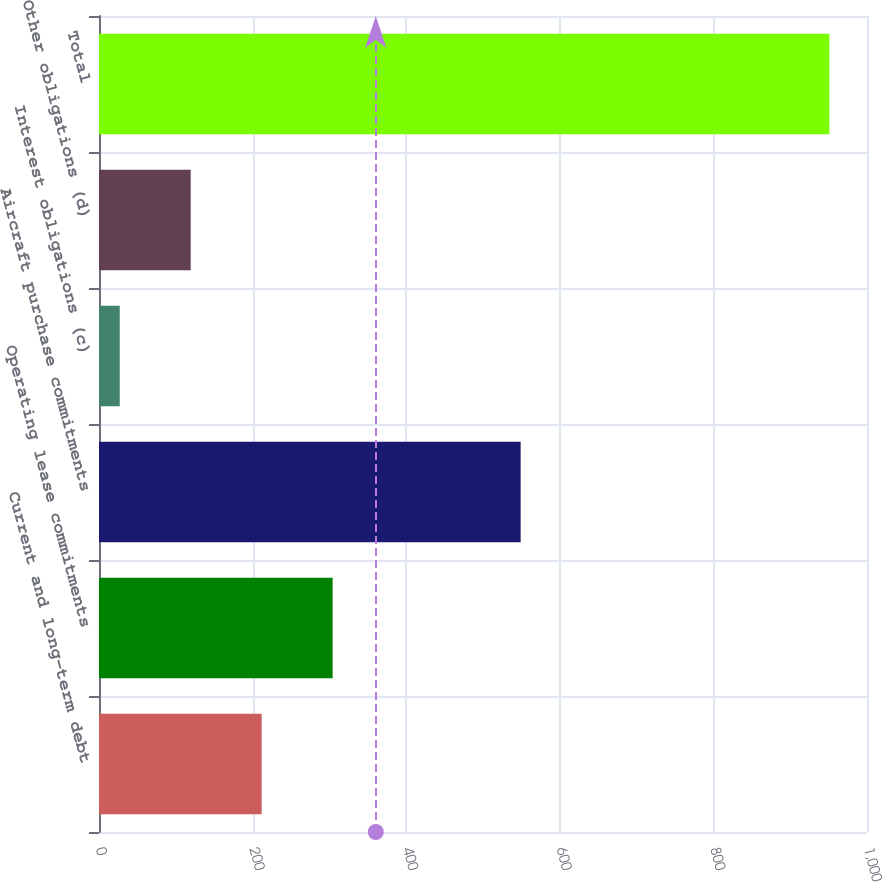Convert chart. <chart><loc_0><loc_0><loc_500><loc_500><bar_chart><fcel>Current and long-term debt<fcel>Operating lease commitments<fcel>Aircraft purchase commitments<fcel>Interest obligations (c)<fcel>Other obligations (d)<fcel>Total<nl><fcel>211.8<fcel>304.2<fcel>549<fcel>27<fcel>119.4<fcel>951<nl></chart> 